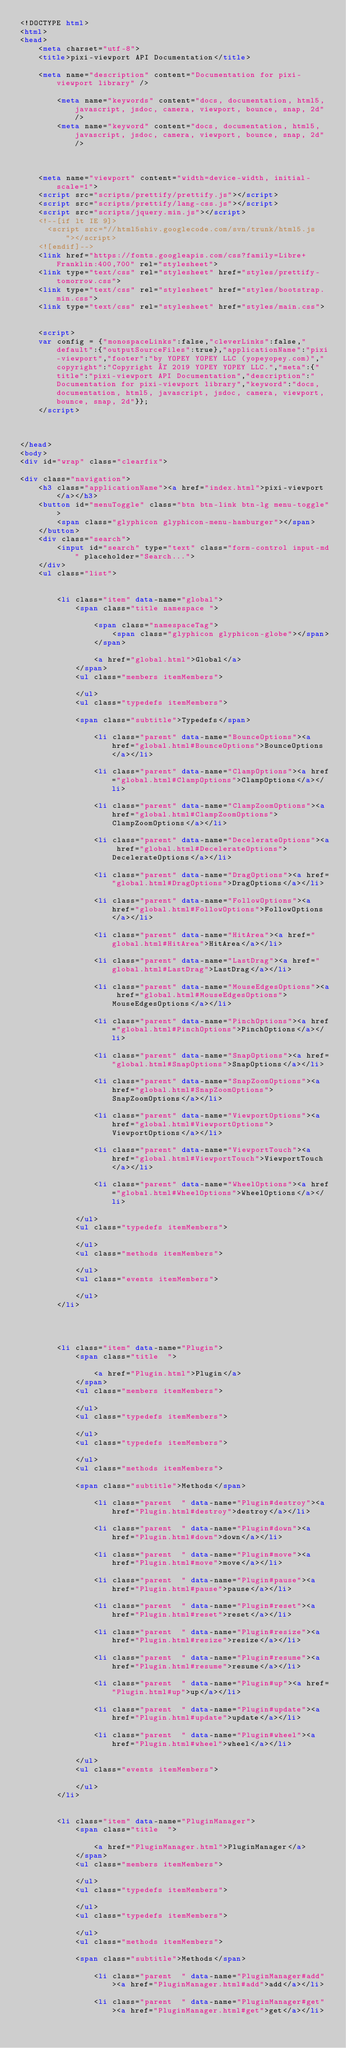Convert code to text. <code><loc_0><loc_0><loc_500><loc_500><_HTML_><!DOCTYPE html>
<html>
<head>
    <meta charset="utf-8">
    <title>pixi-viewport API Documentation</title>
    
    <meta name="description" content="Documentation for pixi-viewport library" />
    
        <meta name="keywords" content="docs, documentation, html5, javascript, jsdoc, camera, viewport, bounce, snap, 2d" />
        <meta name="keyword" content="docs, documentation, html5, javascript, jsdoc, camera, viewport, bounce, snap, 2d" />
    
    
    
    <meta name="viewport" content="width=device-width, initial-scale=1">
    <script src="scripts/prettify/prettify.js"></script>
    <script src="scripts/prettify/lang-css.js"></script>
    <script src="scripts/jquery.min.js"></script>
    <!--[if lt IE 9]>
      <script src="//html5shiv.googlecode.com/svn/trunk/html5.js"></script>
    <![endif]-->
    <link href="https://fonts.googleapis.com/css?family=Libre+Franklin:400,700" rel="stylesheet">
    <link type="text/css" rel="stylesheet" href="styles/prettify-tomorrow.css">
    <link type="text/css" rel="stylesheet" href="styles/bootstrap.min.css">
    <link type="text/css" rel="stylesheet" href="styles/main.css">

    
    <script>
    var config = {"monospaceLinks":false,"cleverLinks":false,"default":{"outputSourceFiles":true},"applicationName":"pixi-viewport","footer":"by YOPEY YOPEY LLC (yopeyopey.com)","copyright":"Copyright © 2019 YOPEY YOPEY LLC.","meta":{"title":"pixi-viewport API Documentation","description":"Documentation for pixi-viewport library","keyword":"docs, documentation, html5, javascript, jsdoc, camera, viewport, bounce, snap, 2d"}};
    </script>
    

    
</head>
<body>
<div id="wrap" class="clearfix">
    
<div class="navigation">
    <h3 class="applicationName"><a href="index.html">pixi-viewport</a></h3>
    <button id="menuToggle" class="btn btn-link btn-lg menu-toggle">
        <span class="glyphicon glyphicon-menu-hamburger"></span>
    </button>
    <div class="search">
        <input id="search" type="text" class="form-control input-md" placeholder="Search...">
    </div>
    <ul class="list">
    
        
        <li class="item" data-name="global">
            <span class="title namespace ">
                
                <span class="namespaceTag">
                    <span class="glyphicon glyphicon-globe"></span>
                </span>
                
                <a href="global.html">Global</a>
            </span>
            <ul class="members itemMembers">
            
            </ul>
            <ul class="typedefs itemMembers">
            
            <span class="subtitle">Typedefs</span>
            
                <li class="parent" data-name="BounceOptions"><a href="global.html#BounceOptions">BounceOptions</a></li>
            
                <li class="parent" data-name="ClampOptions"><a href="global.html#ClampOptions">ClampOptions</a></li>
            
                <li class="parent" data-name="ClampZoomOptions"><a href="global.html#ClampZoomOptions">ClampZoomOptions</a></li>
            
                <li class="parent" data-name="DecelerateOptions"><a href="global.html#DecelerateOptions">DecelerateOptions</a></li>
            
                <li class="parent" data-name="DragOptions"><a href="global.html#DragOptions">DragOptions</a></li>
            
                <li class="parent" data-name="FollowOptions"><a href="global.html#FollowOptions">FollowOptions</a></li>
            
                <li class="parent" data-name="HitArea"><a href="global.html#HitArea">HitArea</a></li>
            
                <li class="parent" data-name="LastDrag"><a href="global.html#LastDrag">LastDrag</a></li>
            
                <li class="parent" data-name="MouseEdgesOptions"><a href="global.html#MouseEdgesOptions">MouseEdgesOptions</a></li>
            
                <li class="parent" data-name="PinchOptions"><a href="global.html#PinchOptions">PinchOptions</a></li>
            
                <li class="parent" data-name="SnapOptions"><a href="global.html#SnapOptions">SnapOptions</a></li>
            
                <li class="parent" data-name="SnapZoomOptions"><a href="global.html#SnapZoomOptions">SnapZoomOptions</a></li>
            
                <li class="parent" data-name="ViewportOptions"><a href="global.html#ViewportOptions">ViewportOptions</a></li>
            
                <li class="parent" data-name="ViewportTouch"><a href="global.html#ViewportTouch">ViewportTouch</a></li>
            
                <li class="parent" data-name="WheelOptions"><a href="global.html#WheelOptions">WheelOptions</a></li>
            
            </ul>
            <ul class="typedefs itemMembers">
            
            </ul>
            <ul class="methods itemMembers">
            
            </ul>
            <ul class="events itemMembers">
            
            </ul>
        </li>
    
        
    
        
        <li class="item" data-name="Plugin">
            <span class="title  ">
                
                <a href="Plugin.html">Plugin</a>
            </span>
            <ul class="members itemMembers">
            
            </ul>
            <ul class="typedefs itemMembers">
            
            </ul>
            <ul class="typedefs itemMembers">
            
            </ul>
            <ul class="methods itemMembers">
            
            <span class="subtitle">Methods</span>
            
                <li class="parent  " data-name="Plugin#destroy"><a href="Plugin.html#destroy">destroy</a></li>
            
                <li class="parent  " data-name="Plugin#down"><a href="Plugin.html#down">down</a></li>
            
                <li class="parent  " data-name="Plugin#move"><a href="Plugin.html#move">move</a></li>
            
                <li class="parent  " data-name="Plugin#pause"><a href="Plugin.html#pause">pause</a></li>
            
                <li class="parent  " data-name="Plugin#reset"><a href="Plugin.html#reset">reset</a></li>
            
                <li class="parent  " data-name="Plugin#resize"><a href="Plugin.html#resize">resize</a></li>
            
                <li class="parent  " data-name="Plugin#resume"><a href="Plugin.html#resume">resume</a></li>
            
                <li class="parent  " data-name="Plugin#up"><a href="Plugin.html#up">up</a></li>
            
                <li class="parent  " data-name="Plugin#update"><a href="Plugin.html#update">update</a></li>
            
                <li class="parent  " data-name="Plugin#wheel"><a href="Plugin.html#wheel">wheel</a></li>
            
            </ul>
            <ul class="events itemMembers">
            
            </ul>
        </li>
    
        
        <li class="item" data-name="PluginManager">
            <span class="title  ">
                
                <a href="PluginManager.html">PluginManager</a>
            </span>
            <ul class="members itemMembers">
            
            </ul>
            <ul class="typedefs itemMembers">
            
            </ul>
            <ul class="typedefs itemMembers">
            
            </ul>
            <ul class="methods itemMembers">
            
            <span class="subtitle">Methods</span>
            
                <li class="parent  " data-name="PluginManager#add"><a href="PluginManager.html#add">add</a></li>
            
                <li class="parent  " data-name="PluginManager#get"><a href="PluginManager.html#get">get</a></li>
            </code> 